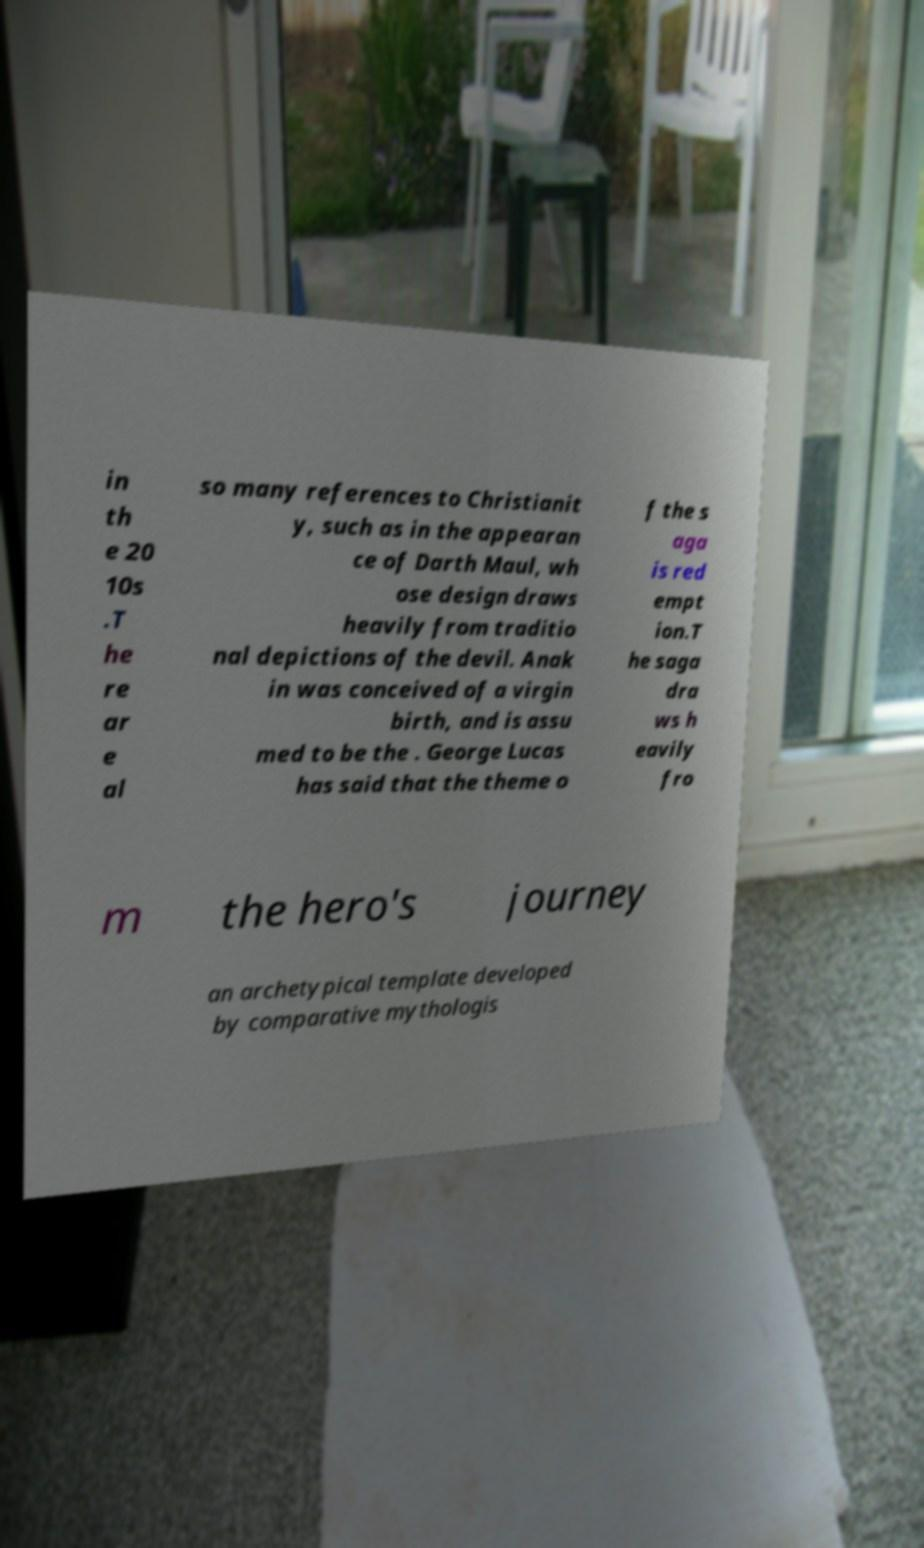There's text embedded in this image that I need extracted. Can you transcribe it verbatim? in th e 20 10s .T he re ar e al so many references to Christianit y, such as in the appearan ce of Darth Maul, wh ose design draws heavily from traditio nal depictions of the devil. Anak in was conceived of a virgin birth, and is assu med to be the . George Lucas has said that the theme o f the s aga is red empt ion.T he saga dra ws h eavily fro m the hero's journey an archetypical template developed by comparative mythologis 